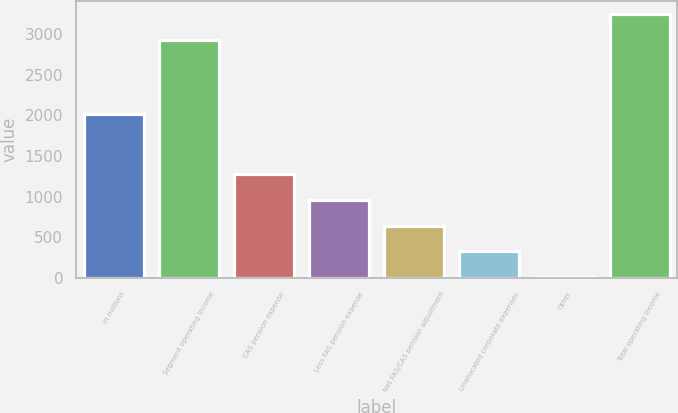<chart> <loc_0><loc_0><loc_500><loc_500><bar_chart><fcel>in millions<fcel>Segment operating income<fcel>CAS pension expense<fcel>Less FAS pension expense<fcel>Net FAS/CAS pension adjustment<fcel>Unallocated corporate expenses<fcel>Other<fcel>Total operating income<nl><fcel>2016<fcel>2935<fcel>1280.2<fcel>961.4<fcel>642.6<fcel>323.8<fcel>5<fcel>3253.8<nl></chart> 